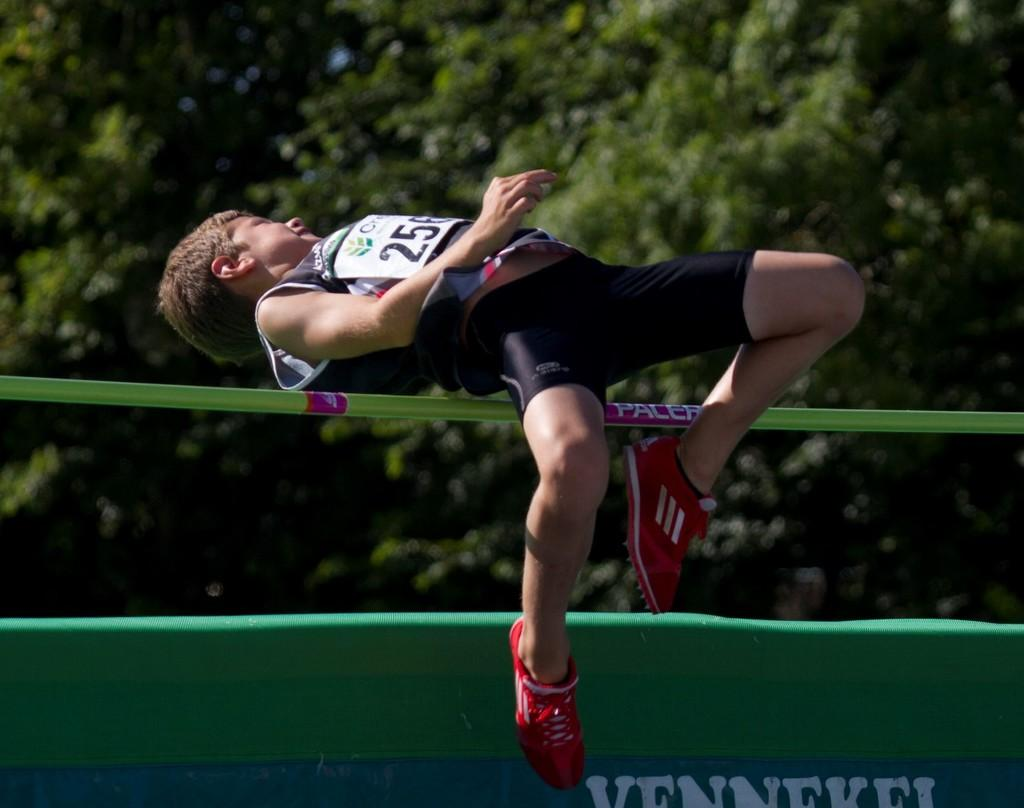<image>
Describe the image concisely. volt poler number 256 jumping over a paler bar 